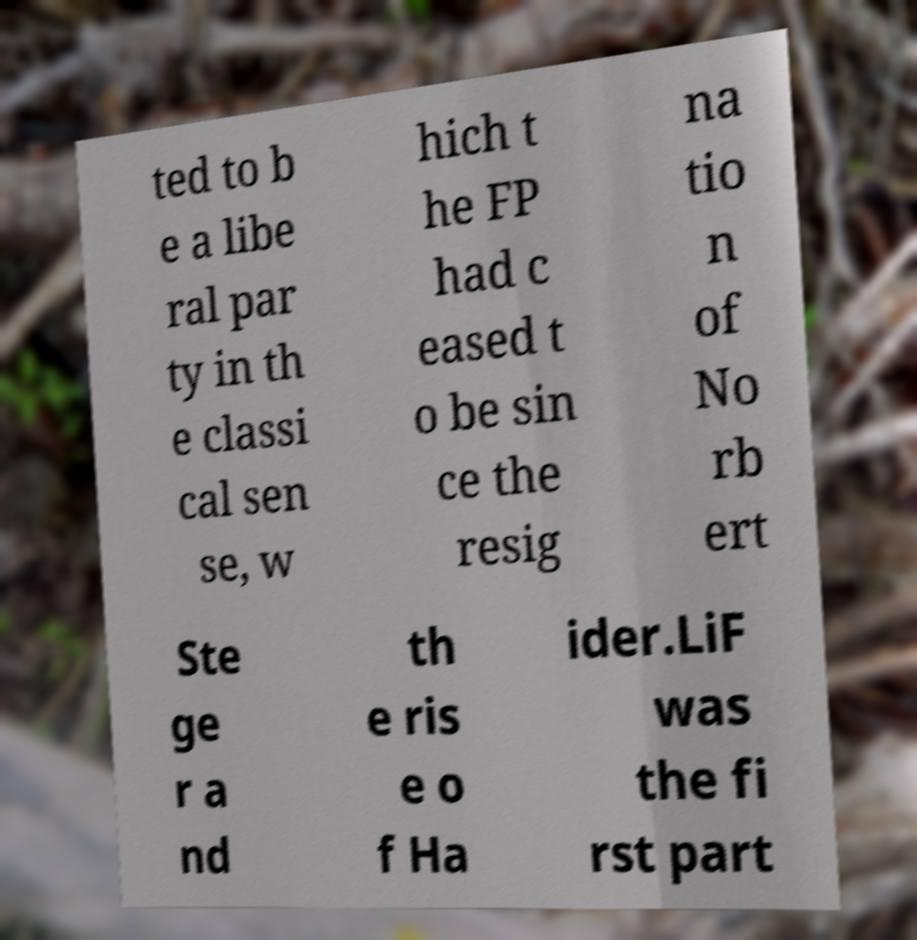Can you accurately transcribe the text from the provided image for me? ted to b e a libe ral par ty in th e classi cal sen se, w hich t he FP had c eased t o be sin ce the resig na tio n of No rb ert Ste ge r a nd th e ris e o f Ha ider.LiF was the fi rst part 